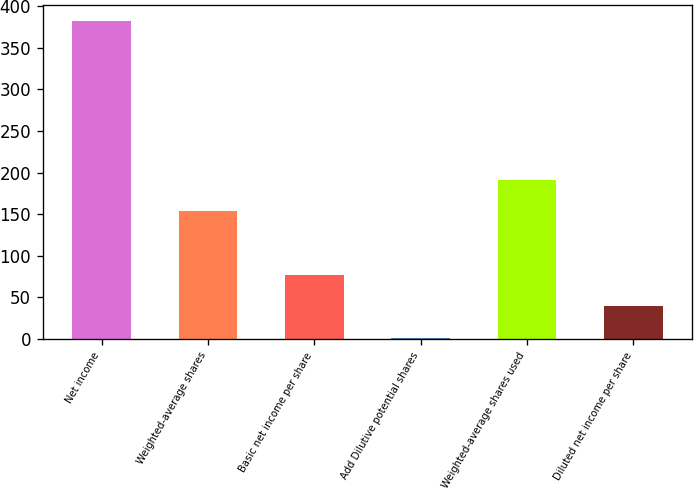<chart> <loc_0><loc_0><loc_500><loc_500><bar_chart><fcel>Net income<fcel>Weighted-average shares<fcel>Basic net income per share<fcel>Add Dilutive potential shares<fcel>Weighted-average shares used<fcel>Diluted net income per share<nl><fcel>381.8<fcel>153.38<fcel>77.24<fcel>1.1<fcel>191.45<fcel>39.17<nl></chart> 